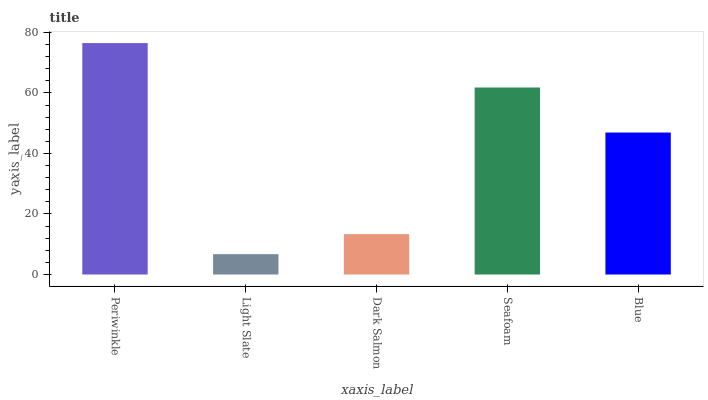Is Light Slate the minimum?
Answer yes or no. Yes. Is Periwinkle the maximum?
Answer yes or no. Yes. Is Dark Salmon the minimum?
Answer yes or no. No. Is Dark Salmon the maximum?
Answer yes or no. No. Is Dark Salmon greater than Light Slate?
Answer yes or no. Yes. Is Light Slate less than Dark Salmon?
Answer yes or no. Yes. Is Light Slate greater than Dark Salmon?
Answer yes or no. No. Is Dark Salmon less than Light Slate?
Answer yes or no. No. Is Blue the high median?
Answer yes or no. Yes. Is Blue the low median?
Answer yes or no. Yes. Is Light Slate the high median?
Answer yes or no. No. Is Dark Salmon the low median?
Answer yes or no. No. 